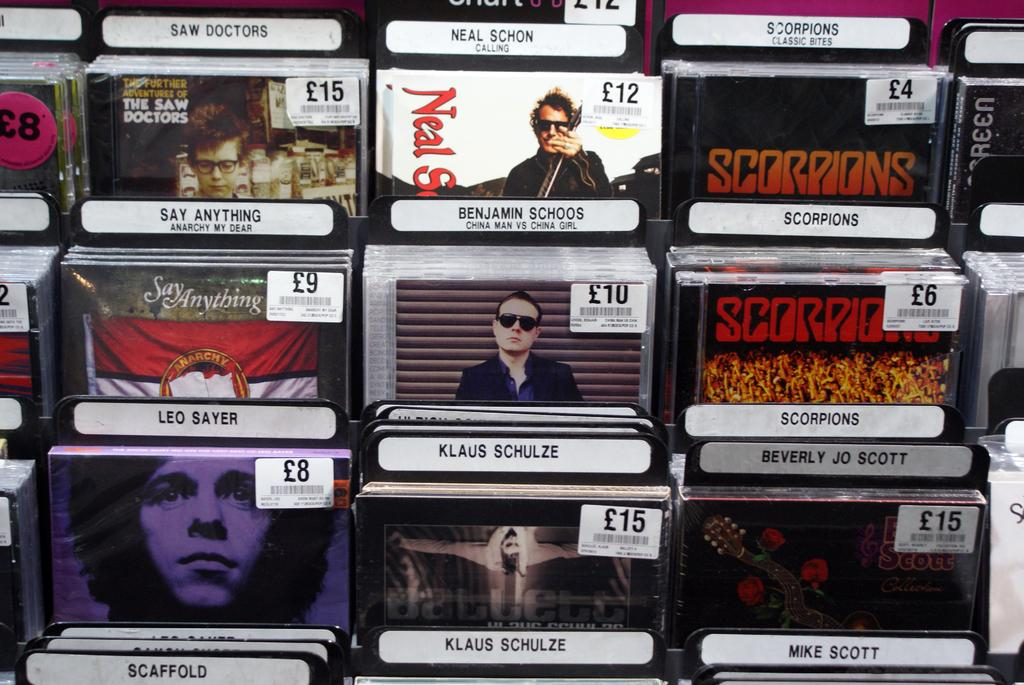What is the arrangement of objects in the image? There are objects placed on a rack in the image. Can you describe the people visible in the image? There are people visible in the image, but their specific actions or characteristics are not mentioned in the provided facts. What additional information can be found on some of the objects? Some objects have text on them. How might the objects be identified or tracked? Some objects have barcodes, which can be used for identification or tracking purposes. How many trees are visible in the image? There are no trees visible in the image; it features objects placed on a rack with people nearby. What type of stitch is used to create the text on the objects? The provided facts do not mention any stitching or textile materials, so it is not possible to determine the type of stitch used. 